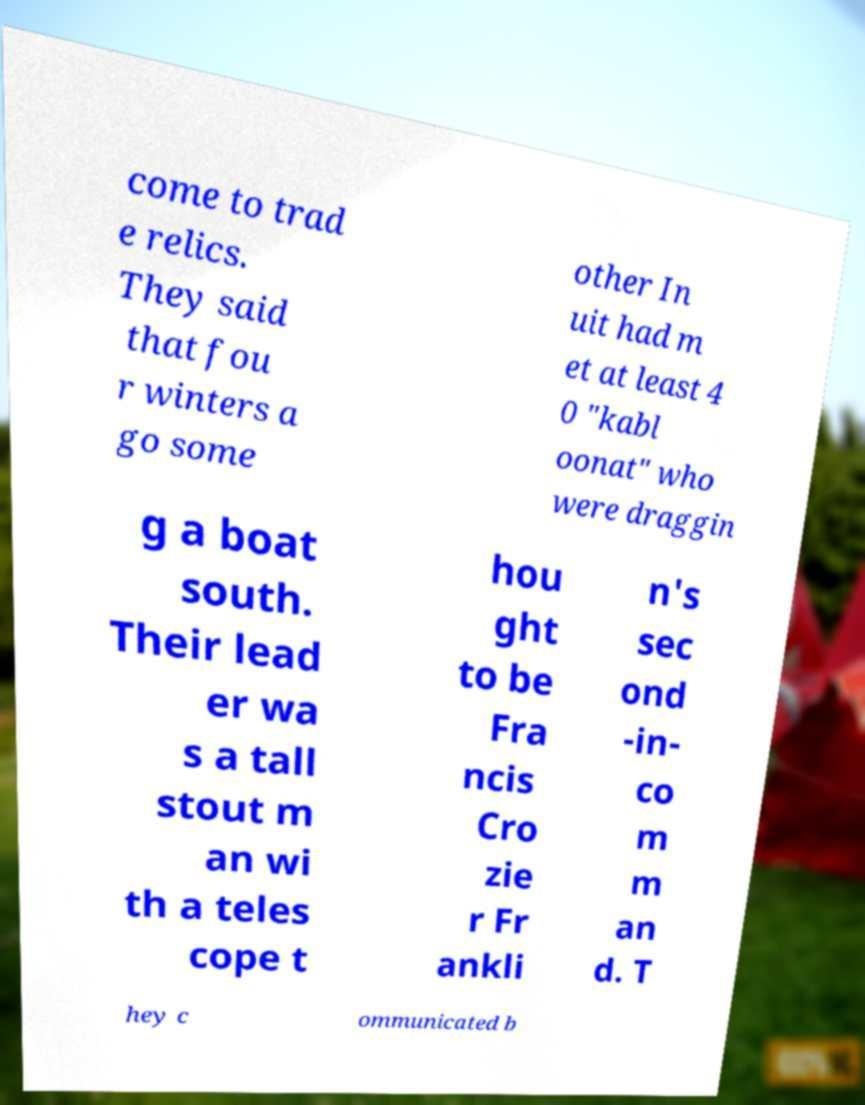There's text embedded in this image that I need extracted. Can you transcribe it verbatim? come to trad e relics. They said that fou r winters a go some other In uit had m et at least 4 0 "kabl oonat" who were draggin g a boat south. Their lead er wa s a tall stout m an wi th a teles cope t hou ght to be Fra ncis Cro zie r Fr ankli n's sec ond -in- co m m an d. T hey c ommunicated b 